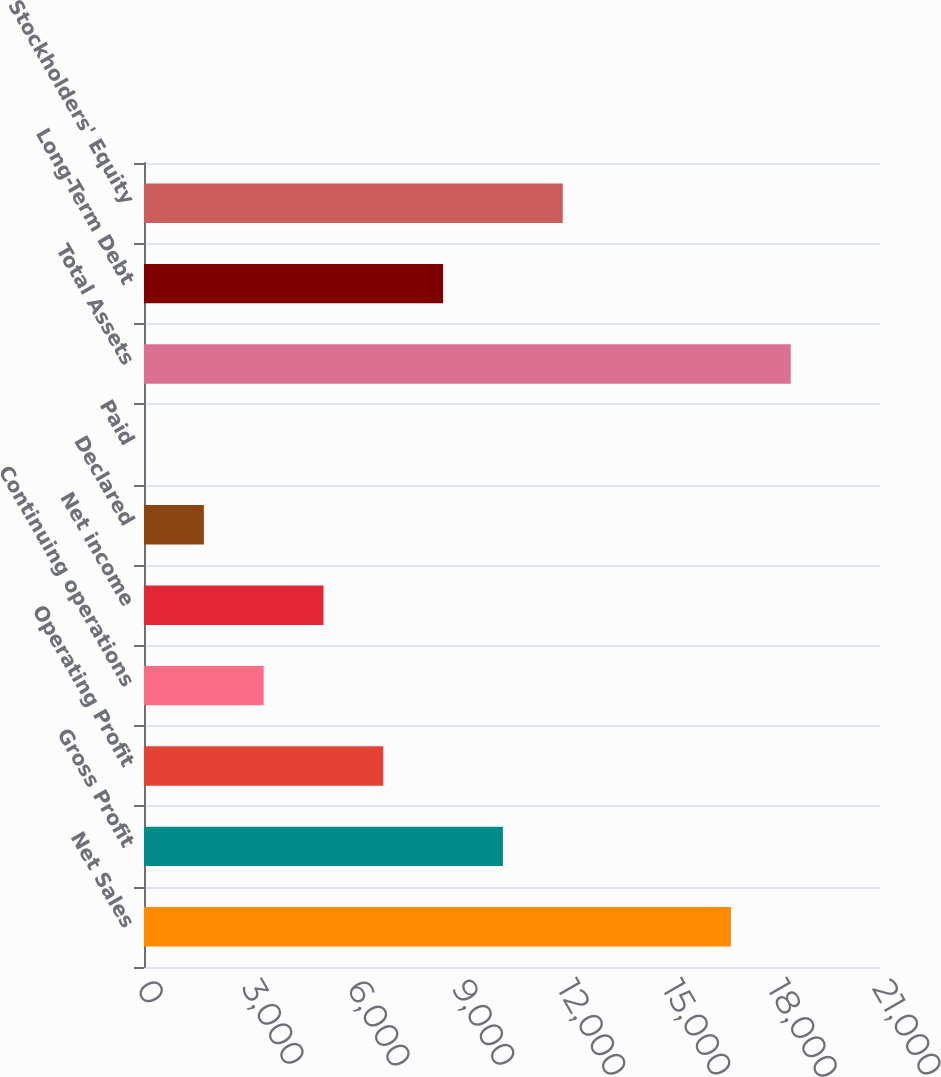<chart> <loc_0><loc_0><loc_500><loc_500><bar_chart><fcel>Net Sales<fcel>Gross Profit<fcel>Operating Profit<fcel>Continuing operations<fcel>Net income<fcel>Declared<fcel>Paid<fcel>Total Assets<fcel>Long-Term Debt<fcel>Stockholders' Equity<nl><fcel>16746.9<fcel>10241<fcel>6827.96<fcel>3414.94<fcel>5121.45<fcel>1708.43<fcel>1.92<fcel>18453.4<fcel>8534.47<fcel>11947.5<nl></chart> 